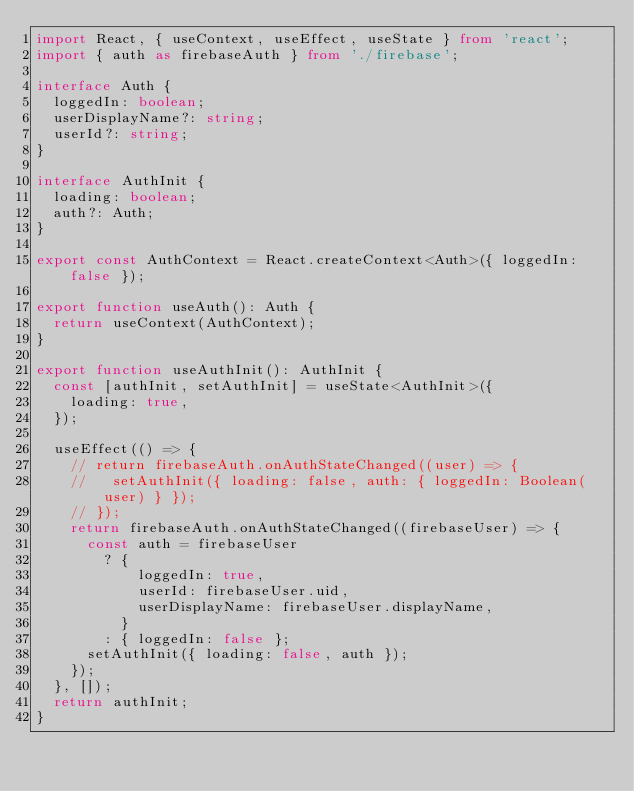Convert code to text. <code><loc_0><loc_0><loc_500><loc_500><_TypeScript_>import React, { useContext, useEffect, useState } from 'react';
import { auth as firebaseAuth } from './firebase';

interface Auth {
  loggedIn: boolean;
  userDisplayName?: string;
  userId?: string;
}

interface AuthInit {
  loading: boolean;
  auth?: Auth;
}

export const AuthContext = React.createContext<Auth>({ loggedIn: false });

export function useAuth(): Auth {
  return useContext(AuthContext);
}

export function useAuthInit(): AuthInit {
  const [authInit, setAuthInit] = useState<AuthInit>({
    loading: true,
  });

  useEffect(() => {
    // return firebaseAuth.onAuthStateChanged((user) => {
    //   setAuthInit({ loading: false, auth: { loggedIn: Boolean(user) } });
    // });
    return firebaseAuth.onAuthStateChanged((firebaseUser) => {
      const auth = firebaseUser
        ? {
            loggedIn: true,
            userId: firebaseUser.uid,
            userDisplayName: firebaseUser.displayName,
          }
        : { loggedIn: false };
      setAuthInit({ loading: false, auth });
    });
  }, []);
  return authInit;
}
</code> 